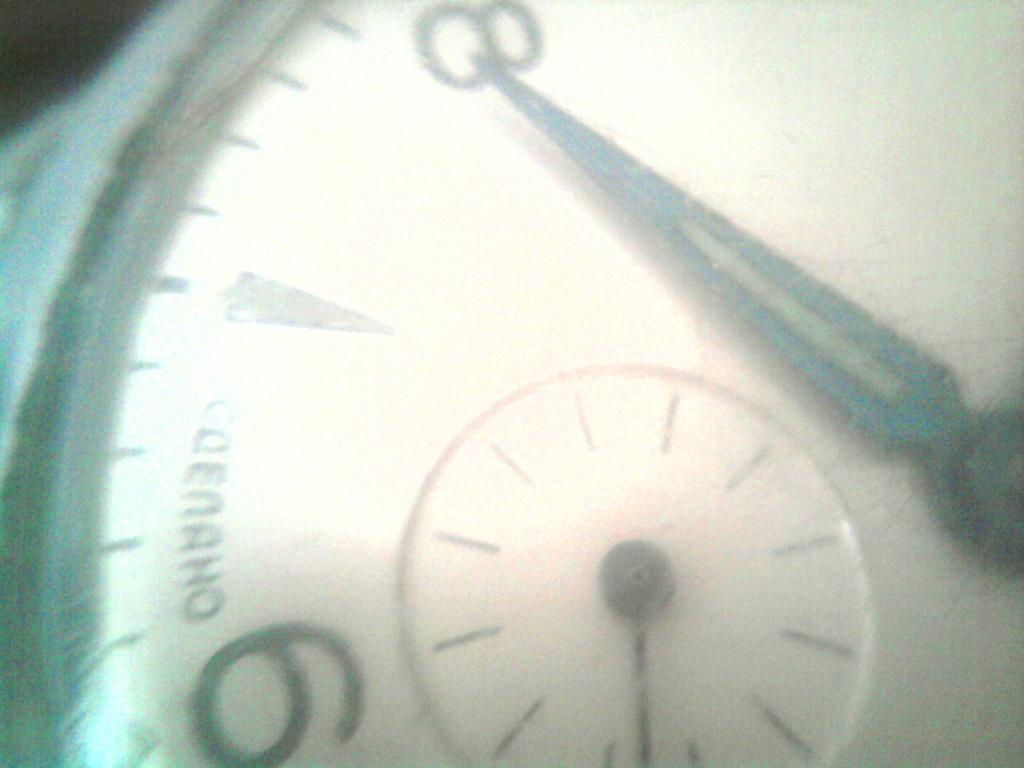<image>
Present a compact description of the photo's key features. White clock that has a hand pointing at the number 8. 